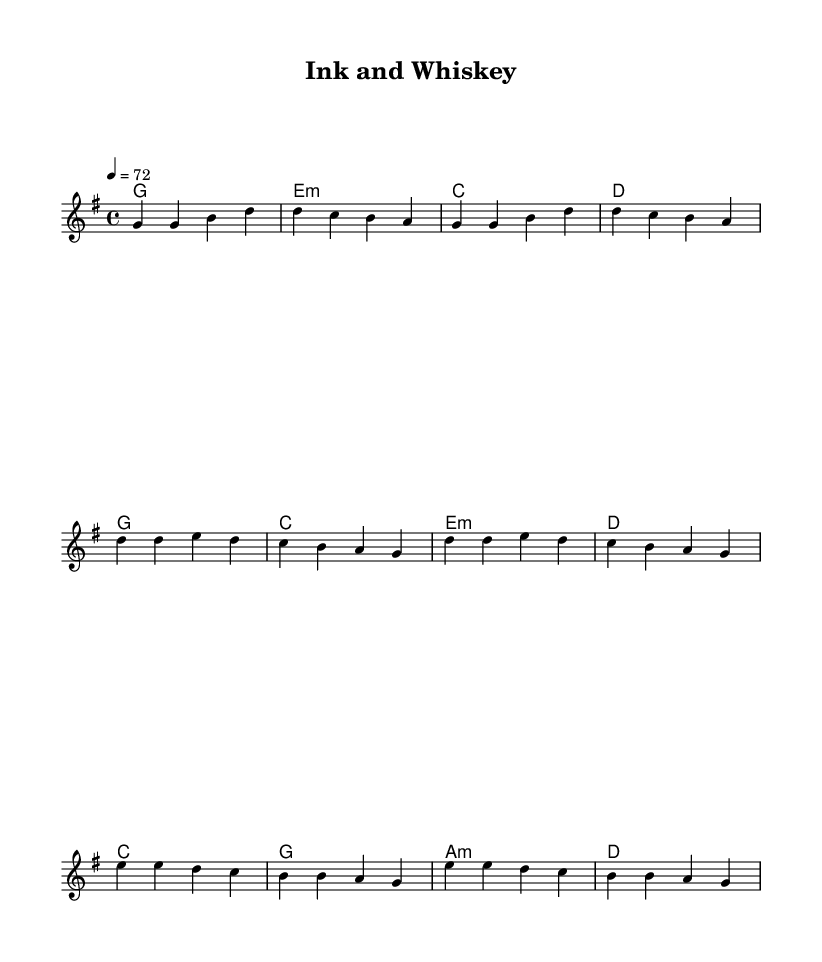What is the key signature of this music? The key signature is G major, which has one sharp (F#).
Answer: G major What is the time signature of the piece? The time signature is 4/4, indicating four beats per measure.
Answer: 4/4 What is the tempo marking in this sheet music? The tempo marking indicates a speed of 72 quarter notes per minute.
Answer: 72 How many chords are present in the verse? There are four distinct chords in the verse section: G, Em, C, and D.
Answer: Four What is the structure of the song based on the music? The structure consists of a verse, chorus, and bridge, indicating a typical narrative arc in country rock.
Answer: Verse, chorus, bridge Which chord comes after the first G chord in the verse? After the first G chord, the next chord is E minor based on the pattern established.
Answer: E minor 